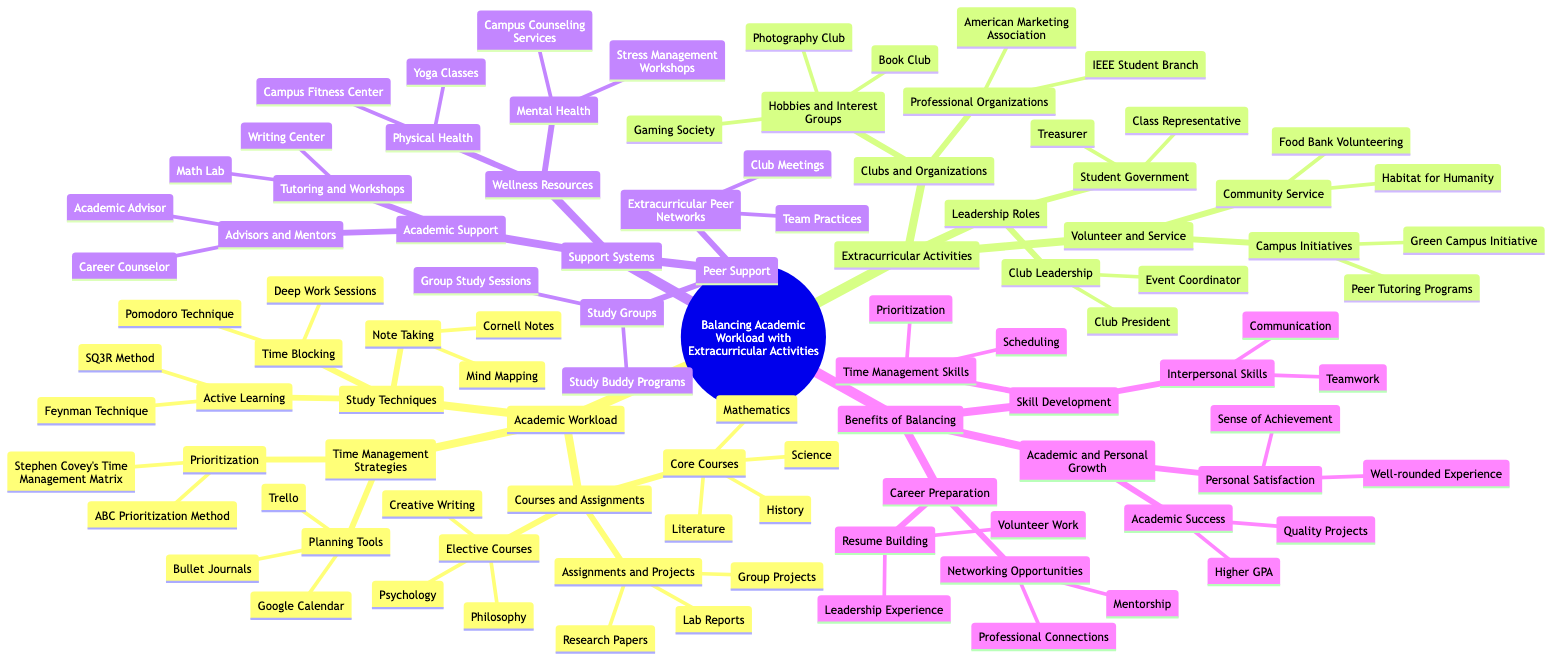What are the core courses listed in the diagram? The core courses can be found under the "Courses and Assignments" section of the "Academic Workload" node. They are specifically listed under "Core Courses," which includes Mathematics, Science, Literature, and History.
Answer: Mathematics, Science, Literature, History How many clubs and organizations are listed in total? To find the total number of clubs and organizations, we look at the "Clubs and Organizations" node under "Extracurricular Activities." There are 2 categories: "Professional Organizations" (which has 2 clubs) and "Hobbies and Interest Groups" (which has 3 clubs), leading to a total of 5 clubs.
Answer: 5 What are the two time management strategies mentioned? The "Time Management Strategies" node under "Academic Workload" shows two subcategories: "Prioritization" and "Planning Tools." Each category has specific items listed; thus, the two strategies can simply be identified from the structure of this node.
Answer: Prioritization, Planning Tools Which volunteer service is a community service activity? In the "Volunteer and Service" section under "Extracurricular Activities," "Community Service" specifically lists activities, where "Habitat for Humanity" is given as an example.
Answer: Habitat for Humanity How does balancing academic workload benefit skill development? The "Benefits of Balancing" section has "Skill Development" as a main node, which branches into "Time Management Skills" and "Interpersonal Skills," both of which highlight how balancing academics and extracurriculars develops these skills.
Answer: Time Management Skills, Interpersonal Skills What are the planning tools listed for time management? Under "Time Management Strategies," the "Planning Tools" category directly lists Google Calendar, Trello, and Bullet Journals as the available tools for maintaining effective planning and organization.
Answer: Google Calendar, Trello, Bullet Journals What are the two categories of support systems identified? In the "Support Systems" section, there are three subdivisions: "Academic Support," "Peer Support," and "Wellness Resources." By identifying the main nodes, we can see the two specified categories more clearly.
Answer: Academic Support, Peer Support How does leadership roles contribute to career preparation? In the "Benefits of Balancing" section, "Career Preparation" includes "Resume Building" and "Networking Opportunities." By analyzing the connections, it's clear that leadership roles like "Class Representative" or "Club President" contribute to these benefits through gained experiences.
Answer: Resume Building, Networking Opportunities 